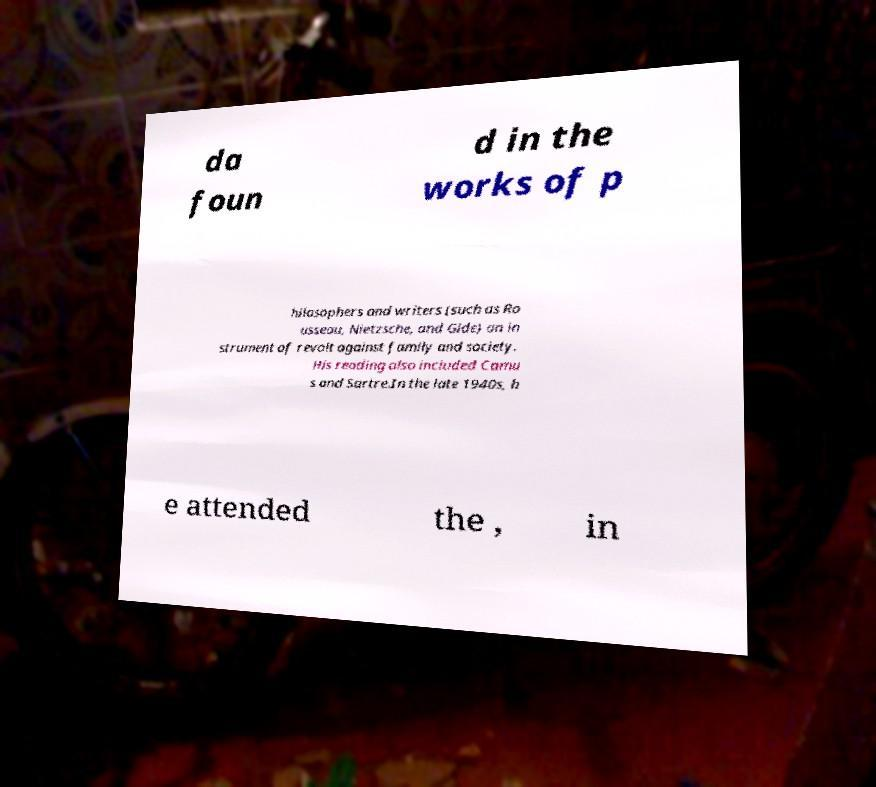Can you read and provide the text displayed in the image?This photo seems to have some interesting text. Can you extract and type it out for me? da foun d in the works of p hilosophers and writers (such as Ro usseau, Nietzsche, and Gide) an in strument of revolt against family and society. His reading also included Camu s and Sartre.In the late 1940s, h e attended the , in 